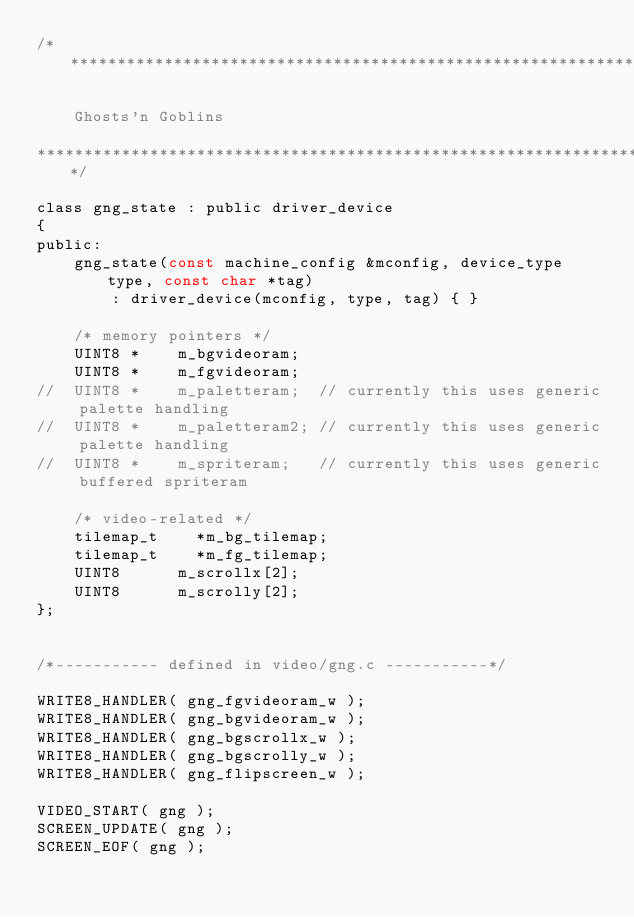<code> <loc_0><loc_0><loc_500><loc_500><_C_>/*************************************************************************

    Ghosts'n Goblins

*************************************************************************/

class gng_state : public driver_device
{
public:
	gng_state(const machine_config &mconfig, device_type type, const char *tag)
		: driver_device(mconfig, type, tag) { }

	/* memory pointers */
	UINT8 *    m_bgvideoram;
	UINT8 *    m_fgvideoram;
//  UINT8 *    m_paletteram;  // currently this uses generic palette handling
//  UINT8 *    m_paletteram2; // currently this uses generic palette handling
//  UINT8 *    m_spriteram;   // currently this uses generic buffered spriteram

	/* video-related */
	tilemap_t    *m_bg_tilemap;
	tilemap_t    *m_fg_tilemap;
	UINT8      m_scrollx[2];
	UINT8      m_scrolly[2];
};


/*----------- defined in video/gng.c -----------*/

WRITE8_HANDLER( gng_fgvideoram_w );
WRITE8_HANDLER( gng_bgvideoram_w );
WRITE8_HANDLER( gng_bgscrollx_w );
WRITE8_HANDLER( gng_bgscrolly_w );
WRITE8_HANDLER( gng_flipscreen_w );

VIDEO_START( gng );
SCREEN_UPDATE( gng );
SCREEN_EOF( gng );
</code> 